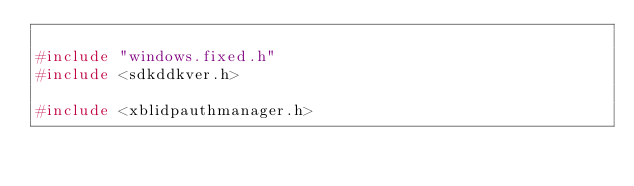<code> <loc_0><loc_0><loc_500><loc_500><_C++_>
#include "windows.fixed.h"
#include <sdkddkver.h>

#include <xblidpauthmanager.h>
</code> 